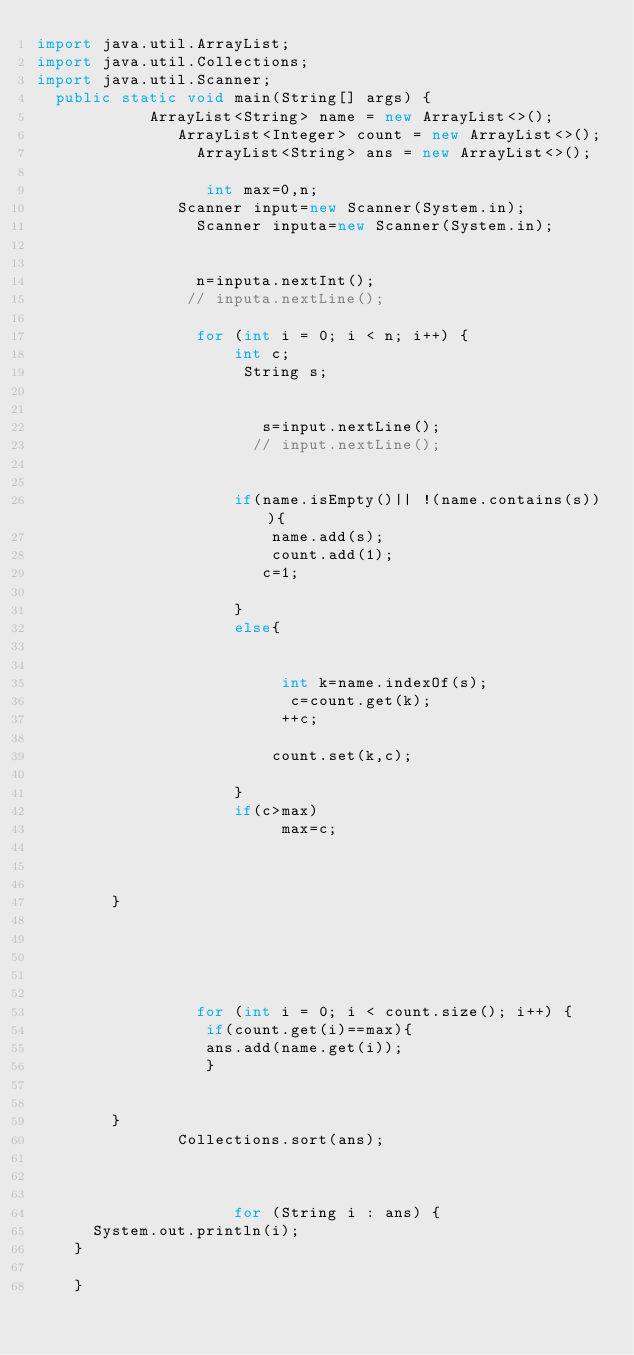Convert code to text. <code><loc_0><loc_0><loc_500><loc_500><_Java_>import java.util.ArrayList;
import java.util.Collections;
import java.util.Scanner;
  public static void main(String[] args) {
            ArrayList<String> name = new ArrayList<>();
               ArrayList<Integer> count = new ArrayList<>();
                 ArrayList<String> ans = new ArrayList<>();
               
                  int max=0,n;
               Scanner input=new Scanner(System.in);
                 Scanner inputa=new Scanner(System.in);
                 
             
                 n=inputa.nextInt();
                // inputa.nextLine();
                 
                 for (int i = 0; i < n; i++) {
                     int c;
                      String s;
                        
                        
                        s=input.nextLine();
                       // input.nextLine();
                 
                 
                     if(name.isEmpty()|| !(name.contains(s))){
                         name.add(s);
                         count.add(1);
                        c=1;
                     
                     }
                     else{
                     
                         
                          int k=name.indexOf(s);
                           c=count.get(k);
                          ++c;
                          
                         count.set(k,c);
                     
                     }
                     if(c>max)
                          max=c;
                     
         
                     
        }
                 
               
                         
                         
                     
                 for (int i = 0; i < count.size(); i++) {
                  if(count.get(i)==max){
                  ans.add(name.get(i));
                  }
                    
            
        }
               Collections.sort(ans);
                 
                
            
                     for (String i : ans) {
      System.out.println(i);
    }
              
    }</code> 